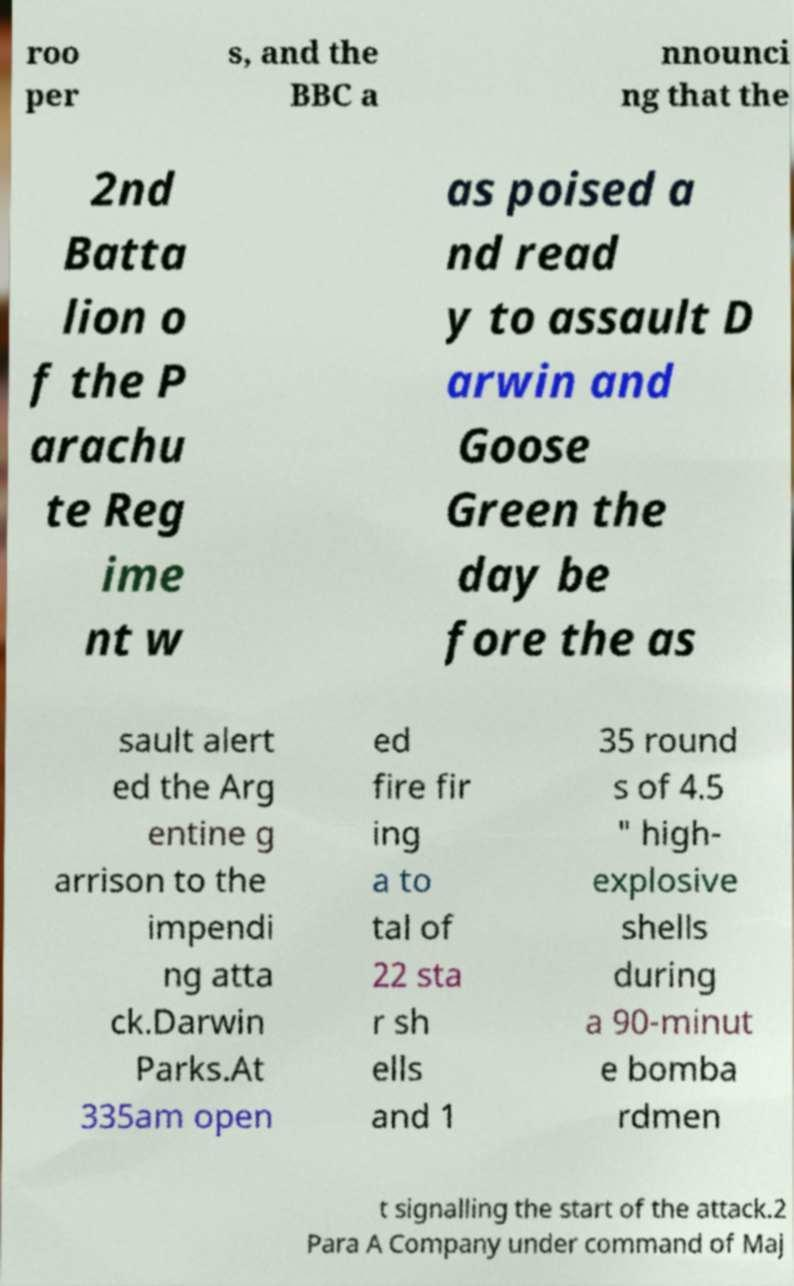Could you extract and type out the text from this image? roo per s, and the BBC a nnounci ng that the 2nd Batta lion o f the P arachu te Reg ime nt w as poised a nd read y to assault D arwin and Goose Green the day be fore the as sault alert ed the Arg entine g arrison to the impendi ng atta ck.Darwin Parks.At 335am open ed fire fir ing a to tal of 22 sta r sh ells and 1 35 round s of 4.5 " high- explosive shells during a 90-minut e bomba rdmen t signalling the start of the attack.2 Para A Company under command of Maj 